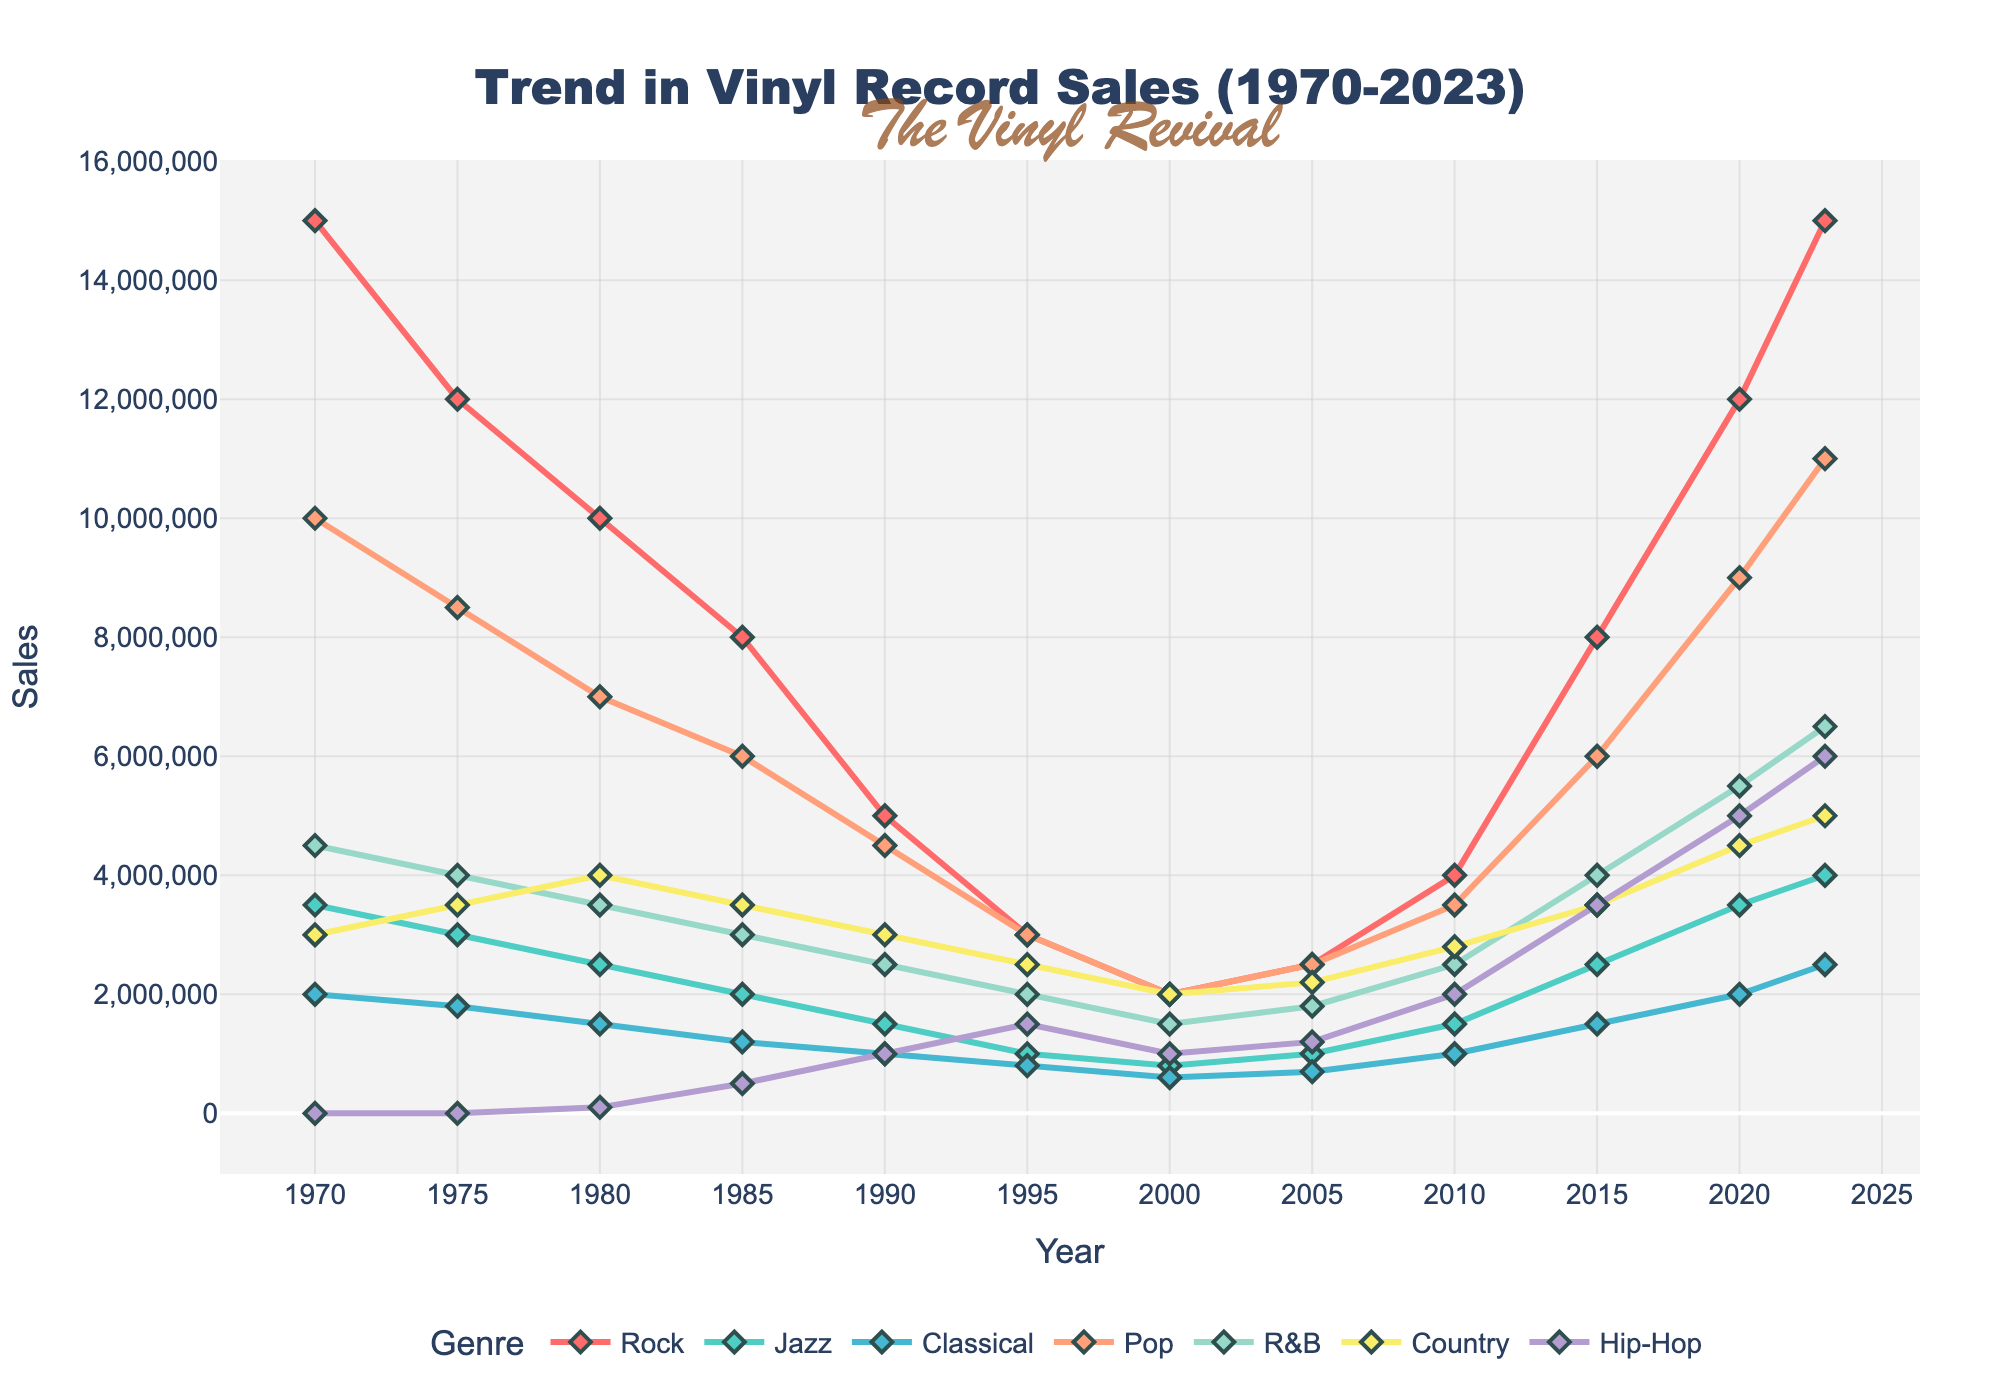What was the trend in sales for Rock music from 1970 to 2023? To determine the trend, observe the line corresponding to Rock music. The sales start at 15,000,000 in 1970, decrease until approximately 1995, and then show a significant increase to 15,000,000 by 2023. This indicates a U-shaped trend.
Answer: U-shaped trend Which genre had the highest sales in 2023? Compare the endpoints of all genre lines in 2023. Rock and Pop both show an endpoint at 15,000,000, but since Rock is listed first, it's identified as having the highest sales.
Answer: Rock What is the combined sales of Jazz and Hip-Hop in 2010? Locate the data points for both Jazz (1,500,000) and Hip-Hop (2,000,000) in 2010. Sum these values: 1,500,000 + 2,000,000.
Answer: 3,500,000 Has Classical music sales ever surpassed 2,000,000? Trace the line for Classical music across all years. It reaches 2,000,000 in 1970 and 2020.
Answer: Yes Between 1980 and 1990, which genre experienced the biggest drop in sales? Examine the lines for all genres between these years. Rock goes from 10,000,000 to 5,000,000, the largest drop among genres, a difference of 5,000,000.
Answer: Rock When did Hip-Hop sales first surpass 2,500,000? Follow the Hip-Hop line and find where it crosses 2,500,000. This happens in 2020, reaching 5,000,000.
Answer: 2020 Which genres had an increasing trend from 2010 to 2023? Inspect the trajectories of each genre line from 2010 to 2023. Rock, Jazz, Classical, Pop, R&B, Country, and Hip-Hop all exhibit an upward trend.
Answer: Rock, Jazz, Classical, Pop, R&B, Country, Hip-Hop In what year were Pop and R&B sales equal? Find where the lines for Pop and R&B intersect. They are equal in 1985 at 6,000,000.
Answer: 1985 What is the average sales of Country music between 1970 and 2000? Find the sales for Country in each corresponding year (3,000,000, 3,500,000, 4,000,000, 3,500,000, 3,000,000, 2,500,000, 2,000,000), sum them (21,500,000), and divide by 7.
Answer: 3,071,429 How many times did Rock music sales drop below 5,000,000? Locate each point where Rock sales are below 5,000,000: once in 1995 (3,000,000).
Answer: Once 